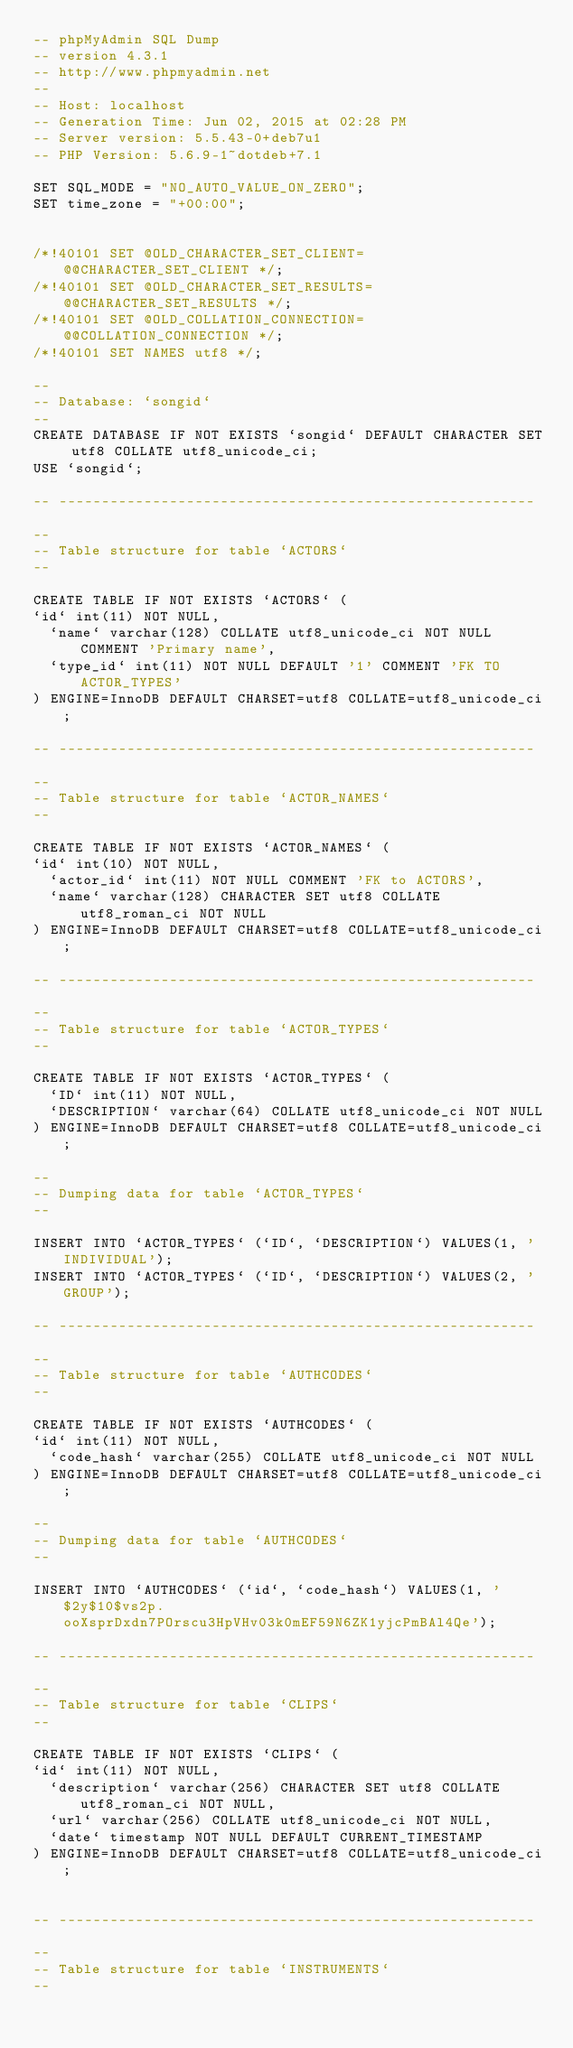Convert code to text. <code><loc_0><loc_0><loc_500><loc_500><_SQL_>-- phpMyAdmin SQL Dump
-- version 4.3.1
-- http://www.phpmyadmin.net
--
-- Host: localhost
-- Generation Time: Jun 02, 2015 at 02:28 PM
-- Server version: 5.5.43-0+deb7u1
-- PHP Version: 5.6.9-1~dotdeb+7.1

SET SQL_MODE = "NO_AUTO_VALUE_ON_ZERO";
SET time_zone = "+00:00";


/*!40101 SET @OLD_CHARACTER_SET_CLIENT=@@CHARACTER_SET_CLIENT */;
/*!40101 SET @OLD_CHARACTER_SET_RESULTS=@@CHARACTER_SET_RESULTS */;
/*!40101 SET @OLD_COLLATION_CONNECTION=@@COLLATION_CONNECTION */;
/*!40101 SET NAMES utf8 */;

--
-- Database: `songid`
--
CREATE DATABASE IF NOT EXISTS `songid` DEFAULT CHARACTER SET utf8 COLLATE utf8_unicode_ci;
USE `songid`;

-- --------------------------------------------------------

--
-- Table structure for table `ACTORS`
--

CREATE TABLE IF NOT EXISTS `ACTORS` (
`id` int(11) NOT NULL,
  `name` varchar(128) COLLATE utf8_unicode_ci NOT NULL COMMENT 'Primary name',
  `type_id` int(11) NOT NULL DEFAULT '1' COMMENT 'FK TO ACTOR_TYPES'
) ENGINE=InnoDB DEFAULT CHARSET=utf8 COLLATE=utf8_unicode_ci;

-- --------------------------------------------------------

--
-- Table structure for table `ACTOR_NAMES`
--

CREATE TABLE IF NOT EXISTS `ACTOR_NAMES` (
`id` int(10) NOT NULL,
  `actor_id` int(11) NOT NULL COMMENT 'FK to ACTORS',
  `name` varchar(128) CHARACTER SET utf8 COLLATE utf8_roman_ci NOT NULL
) ENGINE=InnoDB DEFAULT CHARSET=utf8 COLLATE=utf8_unicode_ci;

-- --------------------------------------------------------

--
-- Table structure for table `ACTOR_TYPES`
--

CREATE TABLE IF NOT EXISTS `ACTOR_TYPES` (
  `ID` int(11) NOT NULL,
  `DESCRIPTION` varchar(64) COLLATE utf8_unicode_ci NOT NULL
) ENGINE=InnoDB DEFAULT CHARSET=utf8 COLLATE=utf8_unicode_ci;

--
-- Dumping data for table `ACTOR_TYPES`
--

INSERT INTO `ACTOR_TYPES` (`ID`, `DESCRIPTION`) VALUES(1, 'INDIVIDUAL');
INSERT INTO `ACTOR_TYPES` (`ID`, `DESCRIPTION`) VALUES(2, 'GROUP');

-- --------------------------------------------------------

--
-- Table structure for table `AUTHCODES`
--

CREATE TABLE IF NOT EXISTS `AUTHCODES` (
`id` int(11) NOT NULL,
  `code_hash` varchar(255) COLLATE utf8_unicode_ci NOT NULL
) ENGINE=InnoDB DEFAULT CHARSET=utf8 COLLATE=utf8_unicode_ci;

--
-- Dumping data for table `AUTHCODES`
--

INSERT INTO `AUTHCODES` (`id`, `code_hash`) VALUES(1, '$2y$10$vs2p.ooXsprDxdn7POrscu3HpVHv03k0mEF59N6ZK1yjcPmBAl4Qe');

-- --------------------------------------------------------

--
-- Table structure for table `CLIPS`
--

CREATE TABLE IF NOT EXISTS `CLIPS` (
`id` int(11) NOT NULL,
  `description` varchar(256) CHARACTER SET utf8 COLLATE utf8_roman_ci NOT NULL,
  `url` varchar(256) COLLATE utf8_unicode_ci NOT NULL,
  `date` timestamp NOT NULL DEFAULT CURRENT_TIMESTAMP
) ENGINE=InnoDB DEFAULT CHARSET=utf8 COLLATE=utf8_unicode_ci;


-- --------------------------------------------------------

--
-- Table structure for table `INSTRUMENTS`
--
</code> 